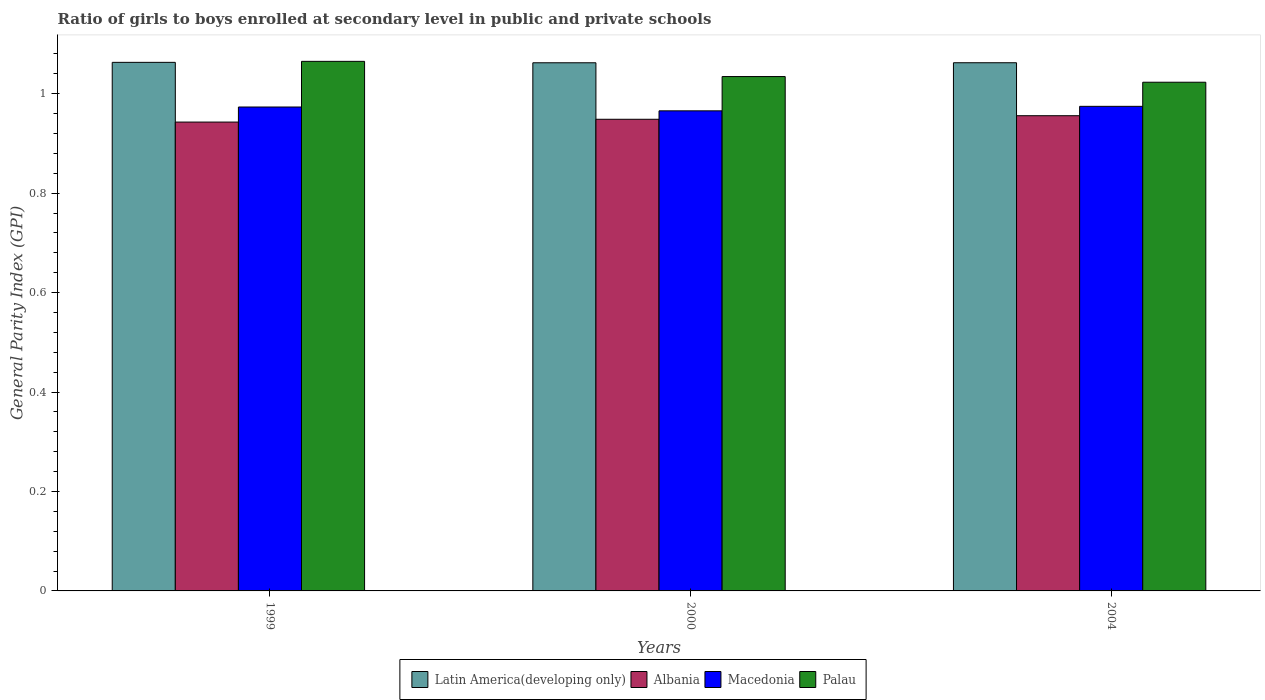Are the number of bars per tick equal to the number of legend labels?
Offer a terse response. Yes. Are the number of bars on each tick of the X-axis equal?
Provide a short and direct response. Yes. How many bars are there on the 3rd tick from the right?
Give a very brief answer. 4. In how many cases, is the number of bars for a given year not equal to the number of legend labels?
Your response must be concise. 0. What is the general parity index in Albania in 1999?
Offer a terse response. 0.94. Across all years, what is the maximum general parity index in Palau?
Ensure brevity in your answer.  1.07. Across all years, what is the minimum general parity index in Palau?
Offer a terse response. 1.02. In which year was the general parity index in Albania minimum?
Your answer should be compact. 1999. What is the total general parity index in Albania in the graph?
Ensure brevity in your answer.  2.85. What is the difference between the general parity index in Latin America(developing only) in 1999 and that in 2000?
Provide a short and direct response. 0. What is the difference between the general parity index in Albania in 2000 and the general parity index in Palau in 1999?
Ensure brevity in your answer.  -0.12. What is the average general parity index in Palau per year?
Your answer should be very brief. 1.04. In the year 2000, what is the difference between the general parity index in Macedonia and general parity index in Latin America(developing only)?
Make the answer very short. -0.1. What is the ratio of the general parity index in Albania in 1999 to that in 2004?
Offer a terse response. 0.99. Is the general parity index in Palau in 1999 less than that in 2004?
Your answer should be compact. No. What is the difference between the highest and the second highest general parity index in Latin America(developing only)?
Your answer should be compact. 0. What is the difference between the highest and the lowest general parity index in Latin America(developing only)?
Your answer should be compact. 0. In how many years, is the general parity index in Albania greater than the average general parity index in Albania taken over all years?
Your response must be concise. 1. What does the 2nd bar from the left in 1999 represents?
Give a very brief answer. Albania. What does the 4th bar from the right in 2004 represents?
Make the answer very short. Latin America(developing only). How many bars are there?
Provide a short and direct response. 12. How many years are there in the graph?
Your answer should be compact. 3. Does the graph contain any zero values?
Provide a short and direct response. No. Where does the legend appear in the graph?
Offer a terse response. Bottom center. How many legend labels are there?
Give a very brief answer. 4. How are the legend labels stacked?
Offer a very short reply. Horizontal. What is the title of the graph?
Ensure brevity in your answer.  Ratio of girls to boys enrolled at secondary level in public and private schools. Does "High income: nonOECD" appear as one of the legend labels in the graph?
Give a very brief answer. No. What is the label or title of the X-axis?
Give a very brief answer. Years. What is the label or title of the Y-axis?
Your answer should be very brief. General Parity Index (GPI). What is the General Parity Index (GPI) in Latin America(developing only) in 1999?
Make the answer very short. 1.06. What is the General Parity Index (GPI) of Albania in 1999?
Provide a short and direct response. 0.94. What is the General Parity Index (GPI) of Macedonia in 1999?
Keep it short and to the point. 0.97. What is the General Parity Index (GPI) in Palau in 1999?
Your response must be concise. 1.07. What is the General Parity Index (GPI) of Latin America(developing only) in 2000?
Your answer should be compact. 1.06. What is the General Parity Index (GPI) in Albania in 2000?
Give a very brief answer. 0.95. What is the General Parity Index (GPI) of Macedonia in 2000?
Provide a short and direct response. 0.97. What is the General Parity Index (GPI) of Palau in 2000?
Give a very brief answer. 1.03. What is the General Parity Index (GPI) of Latin America(developing only) in 2004?
Make the answer very short. 1.06. What is the General Parity Index (GPI) of Albania in 2004?
Your response must be concise. 0.96. What is the General Parity Index (GPI) of Macedonia in 2004?
Make the answer very short. 0.97. What is the General Parity Index (GPI) of Palau in 2004?
Your response must be concise. 1.02. Across all years, what is the maximum General Parity Index (GPI) in Latin America(developing only)?
Keep it short and to the point. 1.06. Across all years, what is the maximum General Parity Index (GPI) in Albania?
Offer a terse response. 0.96. Across all years, what is the maximum General Parity Index (GPI) of Macedonia?
Keep it short and to the point. 0.97. Across all years, what is the maximum General Parity Index (GPI) of Palau?
Provide a short and direct response. 1.07. Across all years, what is the minimum General Parity Index (GPI) of Latin America(developing only)?
Ensure brevity in your answer.  1.06. Across all years, what is the minimum General Parity Index (GPI) in Albania?
Provide a short and direct response. 0.94. Across all years, what is the minimum General Parity Index (GPI) in Macedonia?
Keep it short and to the point. 0.97. Across all years, what is the minimum General Parity Index (GPI) in Palau?
Your answer should be compact. 1.02. What is the total General Parity Index (GPI) of Latin America(developing only) in the graph?
Give a very brief answer. 3.19. What is the total General Parity Index (GPI) of Albania in the graph?
Offer a very short reply. 2.85. What is the total General Parity Index (GPI) in Macedonia in the graph?
Provide a short and direct response. 2.91. What is the total General Parity Index (GPI) in Palau in the graph?
Your response must be concise. 3.12. What is the difference between the General Parity Index (GPI) of Latin America(developing only) in 1999 and that in 2000?
Your answer should be very brief. 0. What is the difference between the General Parity Index (GPI) of Albania in 1999 and that in 2000?
Your answer should be compact. -0.01. What is the difference between the General Parity Index (GPI) of Macedonia in 1999 and that in 2000?
Your response must be concise. 0.01. What is the difference between the General Parity Index (GPI) of Palau in 1999 and that in 2000?
Your answer should be compact. 0.03. What is the difference between the General Parity Index (GPI) in Latin America(developing only) in 1999 and that in 2004?
Provide a short and direct response. 0. What is the difference between the General Parity Index (GPI) of Albania in 1999 and that in 2004?
Keep it short and to the point. -0.01. What is the difference between the General Parity Index (GPI) in Macedonia in 1999 and that in 2004?
Give a very brief answer. -0. What is the difference between the General Parity Index (GPI) in Palau in 1999 and that in 2004?
Provide a short and direct response. 0.04. What is the difference between the General Parity Index (GPI) in Latin America(developing only) in 2000 and that in 2004?
Your response must be concise. -0. What is the difference between the General Parity Index (GPI) of Albania in 2000 and that in 2004?
Make the answer very short. -0.01. What is the difference between the General Parity Index (GPI) in Macedonia in 2000 and that in 2004?
Provide a succinct answer. -0.01. What is the difference between the General Parity Index (GPI) of Palau in 2000 and that in 2004?
Provide a succinct answer. 0.01. What is the difference between the General Parity Index (GPI) of Latin America(developing only) in 1999 and the General Parity Index (GPI) of Albania in 2000?
Offer a terse response. 0.11. What is the difference between the General Parity Index (GPI) of Latin America(developing only) in 1999 and the General Parity Index (GPI) of Macedonia in 2000?
Keep it short and to the point. 0.1. What is the difference between the General Parity Index (GPI) of Latin America(developing only) in 1999 and the General Parity Index (GPI) of Palau in 2000?
Keep it short and to the point. 0.03. What is the difference between the General Parity Index (GPI) of Albania in 1999 and the General Parity Index (GPI) of Macedonia in 2000?
Keep it short and to the point. -0.02. What is the difference between the General Parity Index (GPI) in Albania in 1999 and the General Parity Index (GPI) in Palau in 2000?
Give a very brief answer. -0.09. What is the difference between the General Parity Index (GPI) in Macedonia in 1999 and the General Parity Index (GPI) in Palau in 2000?
Offer a very short reply. -0.06. What is the difference between the General Parity Index (GPI) in Latin America(developing only) in 1999 and the General Parity Index (GPI) in Albania in 2004?
Your response must be concise. 0.11. What is the difference between the General Parity Index (GPI) in Latin America(developing only) in 1999 and the General Parity Index (GPI) in Macedonia in 2004?
Ensure brevity in your answer.  0.09. What is the difference between the General Parity Index (GPI) of Albania in 1999 and the General Parity Index (GPI) of Macedonia in 2004?
Give a very brief answer. -0.03. What is the difference between the General Parity Index (GPI) of Albania in 1999 and the General Parity Index (GPI) of Palau in 2004?
Provide a short and direct response. -0.08. What is the difference between the General Parity Index (GPI) of Macedonia in 1999 and the General Parity Index (GPI) of Palau in 2004?
Your response must be concise. -0.05. What is the difference between the General Parity Index (GPI) in Latin America(developing only) in 2000 and the General Parity Index (GPI) in Albania in 2004?
Provide a succinct answer. 0.11. What is the difference between the General Parity Index (GPI) of Latin America(developing only) in 2000 and the General Parity Index (GPI) of Macedonia in 2004?
Provide a succinct answer. 0.09. What is the difference between the General Parity Index (GPI) in Latin America(developing only) in 2000 and the General Parity Index (GPI) in Palau in 2004?
Provide a succinct answer. 0.04. What is the difference between the General Parity Index (GPI) of Albania in 2000 and the General Parity Index (GPI) of Macedonia in 2004?
Provide a succinct answer. -0.03. What is the difference between the General Parity Index (GPI) of Albania in 2000 and the General Parity Index (GPI) of Palau in 2004?
Give a very brief answer. -0.07. What is the difference between the General Parity Index (GPI) in Macedonia in 2000 and the General Parity Index (GPI) in Palau in 2004?
Provide a succinct answer. -0.06. What is the average General Parity Index (GPI) of Latin America(developing only) per year?
Offer a very short reply. 1.06. What is the average General Parity Index (GPI) of Albania per year?
Give a very brief answer. 0.95. What is the average General Parity Index (GPI) of Macedonia per year?
Your answer should be compact. 0.97. What is the average General Parity Index (GPI) in Palau per year?
Your answer should be compact. 1.04. In the year 1999, what is the difference between the General Parity Index (GPI) of Latin America(developing only) and General Parity Index (GPI) of Albania?
Your answer should be very brief. 0.12. In the year 1999, what is the difference between the General Parity Index (GPI) of Latin America(developing only) and General Parity Index (GPI) of Macedonia?
Your answer should be very brief. 0.09. In the year 1999, what is the difference between the General Parity Index (GPI) in Latin America(developing only) and General Parity Index (GPI) in Palau?
Make the answer very short. -0. In the year 1999, what is the difference between the General Parity Index (GPI) of Albania and General Parity Index (GPI) of Macedonia?
Your response must be concise. -0.03. In the year 1999, what is the difference between the General Parity Index (GPI) of Albania and General Parity Index (GPI) of Palau?
Provide a short and direct response. -0.12. In the year 1999, what is the difference between the General Parity Index (GPI) in Macedonia and General Parity Index (GPI) in Palau?
Give a very brief answer. -0.09. In the year 2000, what is the difference between the General Parity Index (GPI) of Latin America(developing only) and General Parity Index (GPI) of Albania?
Make the answer very short. 0.11. In the year 2000, what is the difference between the General Parity Index (GPI) in Latin America(developing only) and General Parity Index (GPI) in Macedonia?
Keep it short and to the point. 0.1. In the year 2000, what is the difference between the General Parity Index (GPI) in Latin America(developing only) and General Parity Index (GPI) in Palau?
Your response must be concise. 0.03. In the year 2000, what is the difference between the General Parity Index (GPI) in Albania and General Parity Index (GPI) in Macedonia?
Provide a succinct answer. -0.02. In the year 2000, what is the difference between the General Parity Index (GPI) in Albania and General Parity Index (GPI) in Palau?
Provide a short and direct response. -0.09. In the year 2000, what is the difference between the General Parity Index (GPI) in Macedonia and General Parity Index (GPI) in Palau?
Give a very brief answer. -0.07. In the year 2004, what is the difference between the General Parity Index (GPI) of Latin America(developing only) and General Parity Index (GPI) of Albania?
Ensure brevity in your answer.  0.11. In the year 2004, what is the difference between the General Parity Index (GPI) of Latin America(developing only) and General Parity Index (GPI) of Macedonia?
Keep it short and to the point. 0.09. In the year 2004, what is the difference between the General Parity Index (GPI) of Latin America(developing only) and General Parity Index (GPI) of Palau?
Provide a short and direct response. 0.04. In the year 2004, what is the difference between the General Parity Index (GPI) in Albania and General Parity Index (GPI) in Macedonia?
Offer a terse response. -0.02. In the year 2004, what is the difference between the General Parity Index (GPI) in Albania and General Parity Index (GPI) in Palau?
Offer a terse response. -0.07. In the year 2004, what is the difference between the General Parity Index (GPI) in Macedonia and General Parity Index (GPI) in Palau?
Your response must be concise. -0.05. What is the ratio of the General Parity Index (GPI) in Macedonia in 1999 to that in 2000?
Provide a short and direct response. 1.01. What is the ratio of the General Parity Index (GPI) in Palau in 1999 to that in 2000?
Offer a very short reply. 1.03. What is the ratio of the General Parity Index (GPI) in Albania in 1999 to that in 2004?
Ensure brevity in your answer.  0.99. What is the ratio of the General Parity Index (GPI) in Palau in 1999 to that in 2004?
Ensure brevity in your answer.  1.04. What is the ratio of the General Parity Index (GPI) of Macedonia in 2000 to that in 2004?
Give a very brief answer. 0.99. What is the ratio of the General Parity Index (GPI) in Palau in 2000 to that in 2004?
Your response must be concise. 1.01. What is the difference between the highest and the second highest General Parity Index (GPI) of Latin America(developing only)?
Provide a succinct answer. 0. What is the difference between the highest and the second highest General Parity Index (GPI) of Albania?
Keep it short and to the point. 0.01. What is the difference between the highest and the second highest General Parity Index (GPI) of Macedonia?
Offer a very short reply. 0. What is the difference between the highest and the second highest General Parity Index (GPI) in Palau?
Offer a very short reply. 0.03. What is the difference between the highest and the lowest General Parity Index (GPI) of Latin America(developing only)?
Ensure brevity in your answer.  0. What is the difference between the highest and the lowest General Parity Index (GPI) of Albania?
Ensure brevity in your answer.  0.01. What is the difference between the highest and the lowest General Parity Index (GPI) in Macedonia?
Make the answer very short. 0.01. What is the difference between the highest and the lowest General Parity Index (GPI) in Palau?
Offer a terse response. 0.04. 